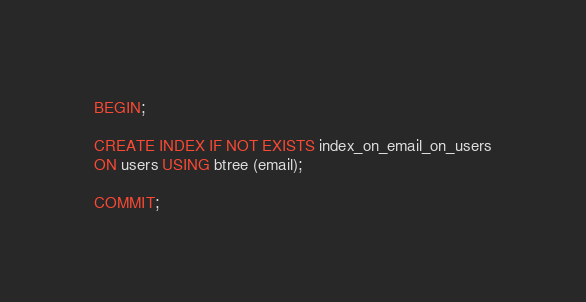Convert code to text. <code><loc_0><loc_0><loc_500><loc_500><_SQL_>BEGIN;

CREATE INDEX IF NOT EXISTS index_on_email_on_users
ON users USING btree (email);

COMMIT;</code> 